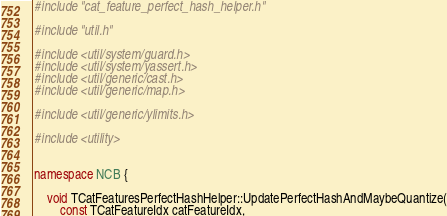Convert code to text. <code><loc_0><loc_0><loc_500><loc_500><_C++_>#include "cat_feature_perfect_hash_helper.h"

#include "util.h"

#include <util/system/guard.h>
#include <util/system/yassert.h>
#include <util/generic/cast.h>
#include <util/generic/map.h>

#include <util/generic/ylimits.h>

#include <utility>


namespace NCB {

    void TCatFeaturesPerfectHashHelper::UpdatePerfectHashAndMaybeQuantize(
        const TCatFeatureIdx catFeatureIdx,</code> 